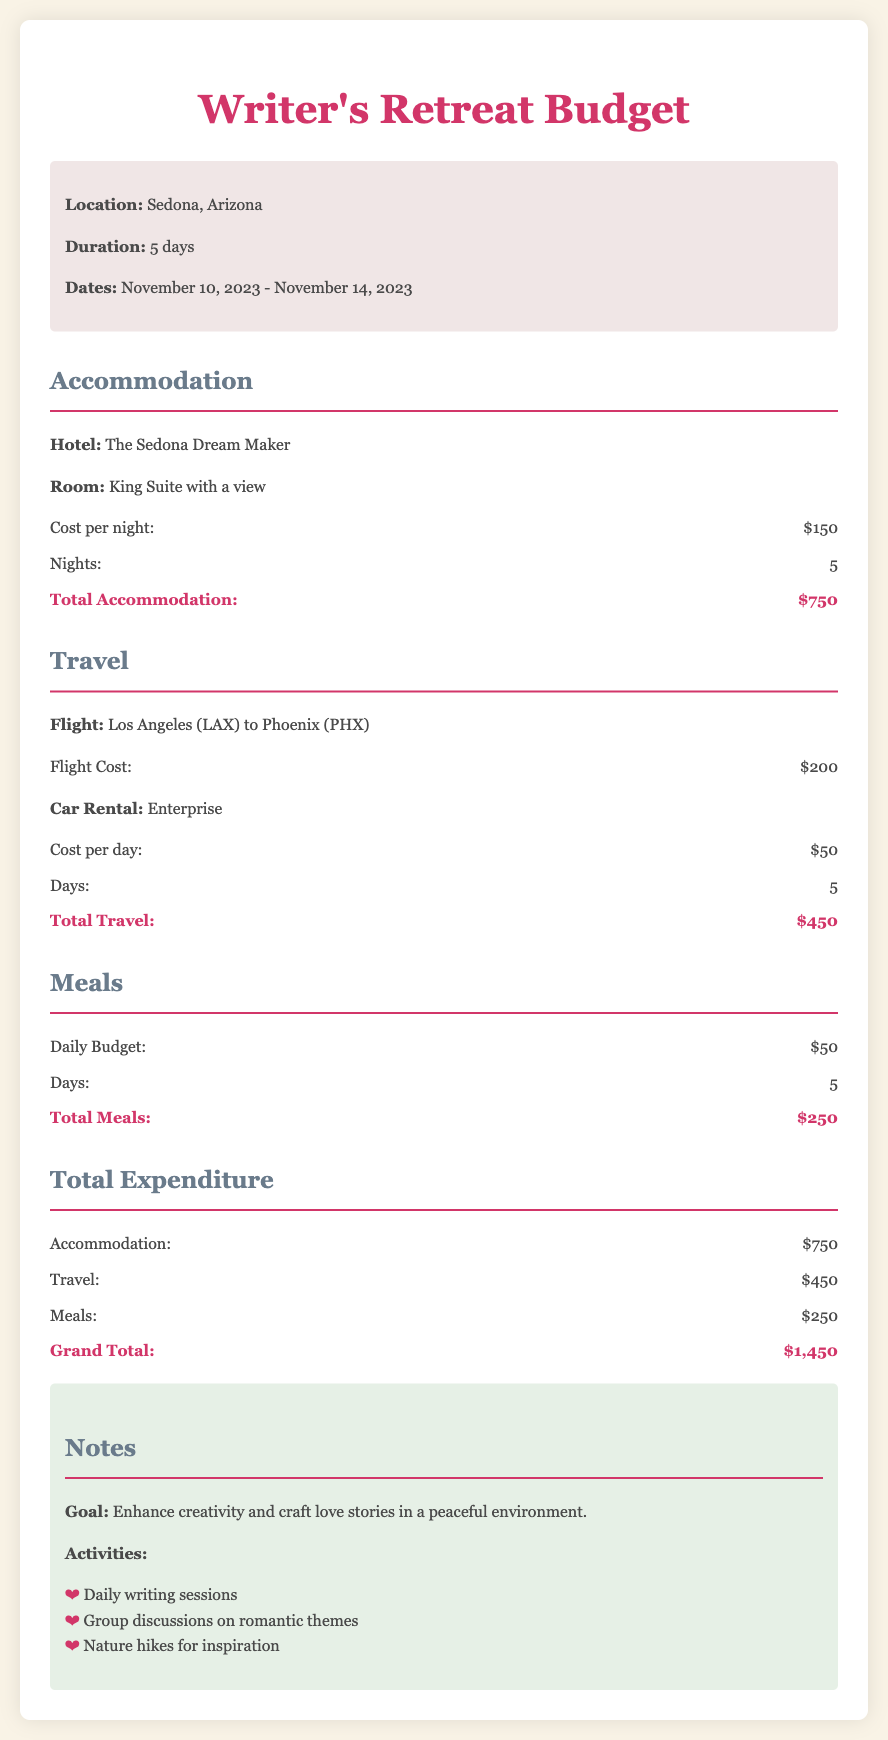what is the location of the retreat? The location is mentioned in the document as Sedona, Arizona.
Answer: Sedona, Arizona how many days is the retreat? The duration of the retreat is specified in the document as 5 days.
Answer: 5 days what is the total accommodation cost? The document lists the total accommodation cost as $750.
Answer: $750 what is the daily budget for meals? The daily budget for meals is stated as $50.
Answer: $50 what is the total expenditure of the retreat? The grand total expenditure is calculated in the document as $1,450.
Answer: $1,450 what type of hotel is mentioned in the budget? The document specifies the hotel type as The Sedona Dream Maker.
Answer: The Sedona Dream Maker how much is the flight cost? The flight cost from Los Angeles to Phoenix is listed as $200.
Answer: $200 how many activities are listed in the notes section? The notes section mentions three activities for the retreat.
Answer: 3 what is the goal of the retreat? The goal of the retreat is stated as enhancing creativity and crafting love stories.
Answer: Enhance creativity and craft love stories 